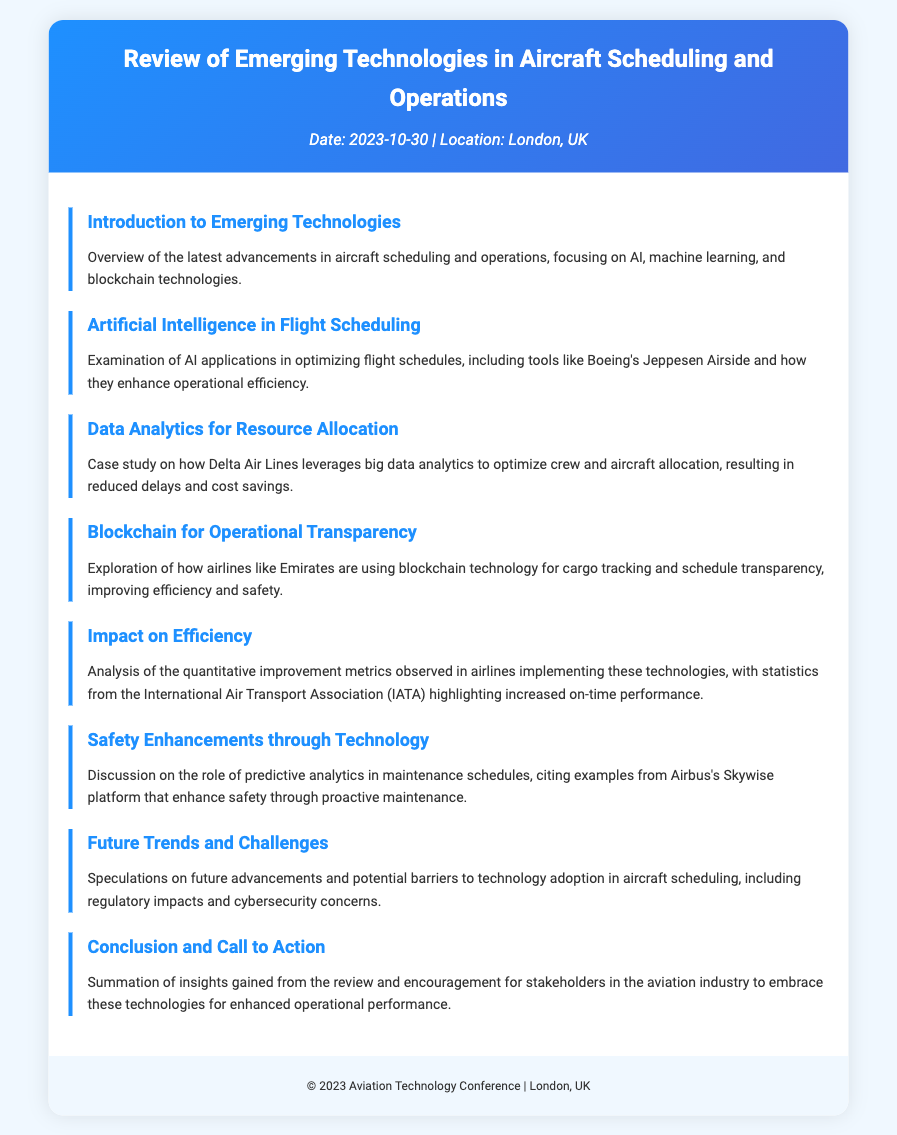What is the title of the document? The title is clearly stated at the top of the document within the header section.
Answer: Review of Emerging Technologies in Aircraft Scheduling and Operations When was the event scheduled? The date is mentioned in the meta section of the header.
Answer: 2023-10-30 Where is the location of the event? The location is also listed in the meta section of the header.
Answer: London, UK Which airline is mentioned as leveraging big data analytics? The specific airline referenced in the context of data analytics for resource allocation is identified in the section about data analytics.
Answer: Delta Air Lines What technology does Airbus's Skywise platform enhance? The context of safety enhancements discusses a particular technology used by Airbus.
Answer: Predictive analytics What is one of the technologies discussed in the Introduction? The introduction section lists various technologies relevant to aircraft scheduling and operations.
Answer: AI What is the main focus of the "Impact on Efficiency" section? This section contains an analysis highlighting specific metrics related to airline performance improvements.
Answer: Quantitative improvement metrics What is a challenge mentioned regarding technology adoption? Future trends and challenges section also highlights potential issues that could affect technology implementation.
Answer: Cybersecurity concerns 